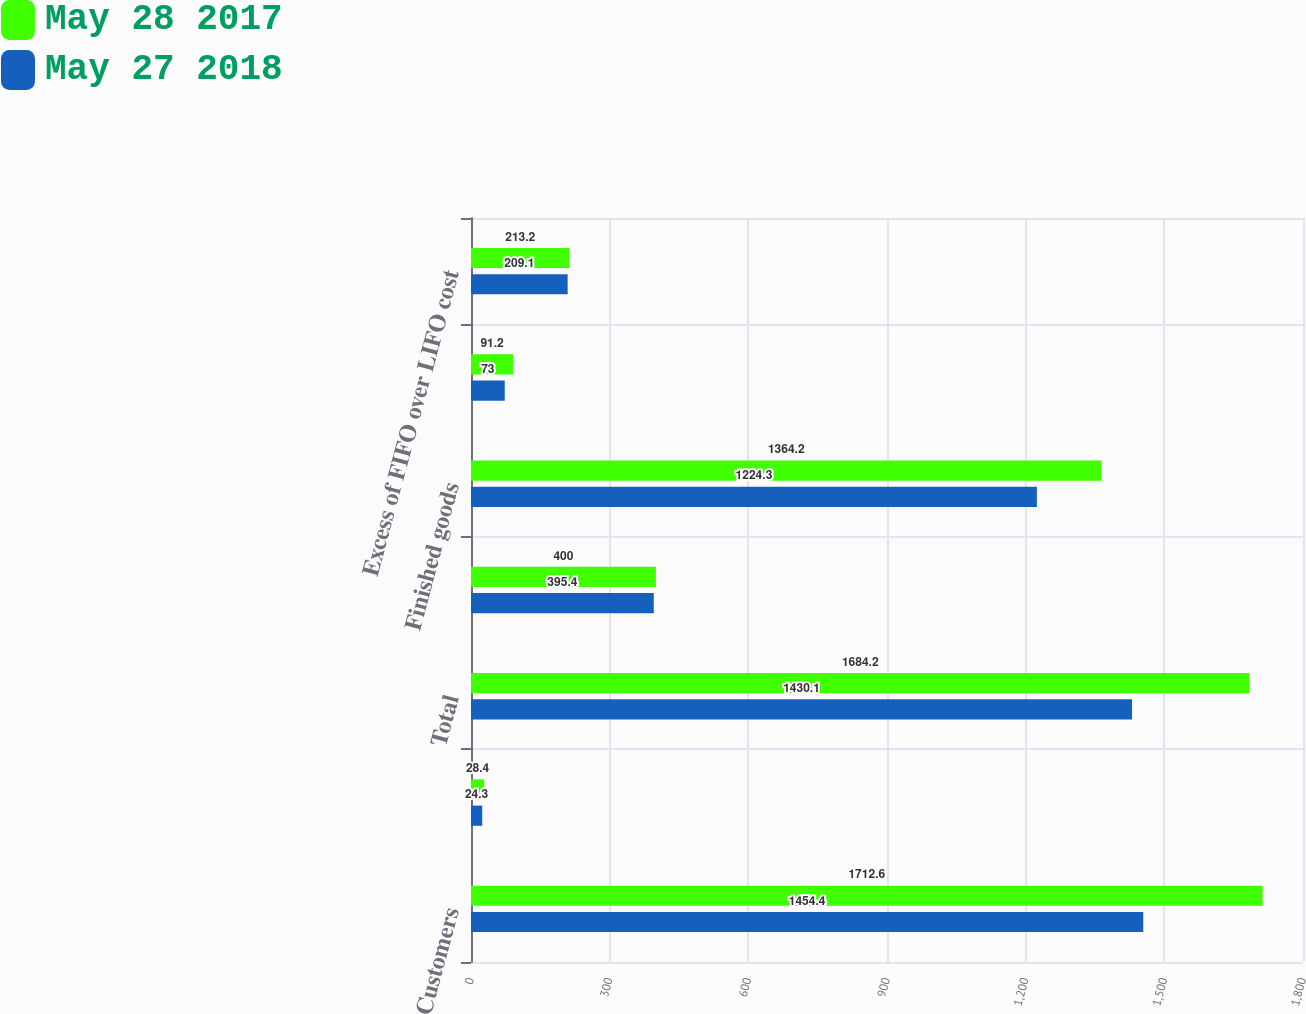Convert chart. <chart><loc_0><loc_0><loc_500><loc_500><stacked_bar_chart><ecel><fcel>Customers<fcel>Less allowance for doubtful<fcel>Total<fcel>Raw materials and packaging<fcel>Finished goods<fcel>Grain<fcel>Excess of FIFO over LIFO cost<nl><fcel>May 28 2017<fcel>1712.6<fcel>28.4<fcel>1684.2<fcel>400<fcel>1364.2<fcel>91.2<fcel>213.2<nl><fcel>May 27 2018<fcel>1454.4<fcel>24.3<fcel>1430.1<fcel>395.4<fcel>1224.3<fcel>73<fcel>209.1<nl></chart> 